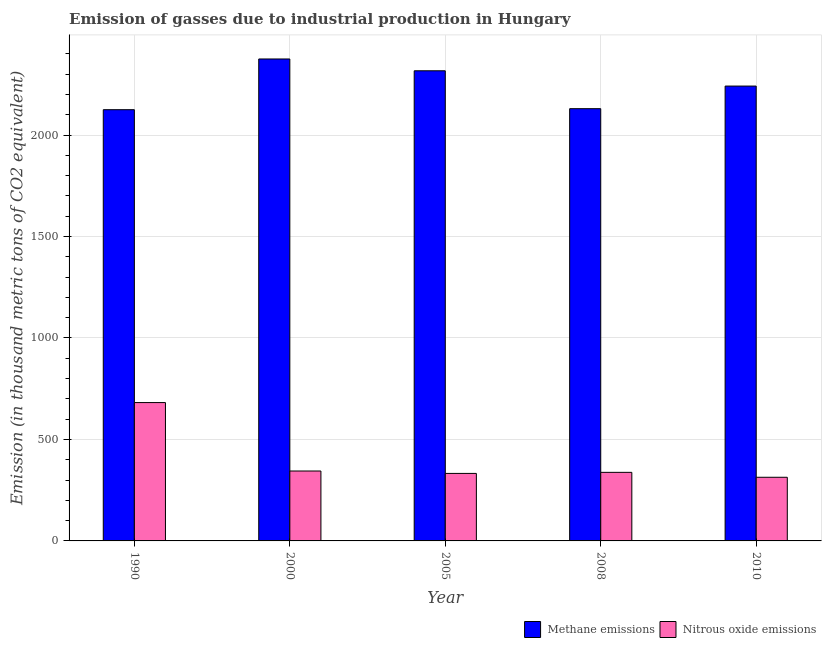How many different coloured bars are there?
Provide a succinct answer. 2. How many groups of bars are there?
Provide a short and direct response. 5. Are the number of bars on each tick of the X-axis equal?
Give a very brief answer. Yes. What is the label of the 2nd group of bars from the left?
Your response must be concise. 2000. What is the amount of nitrous oxide emissions in 2008?
Offer a very short reply. 337.9. Across all years, what is the maximum amount of nitrous oxide emissions?
Your answer should be compact. 681.7. Across all years, what is the minimum amount of nitrous oxide emissions?
Provide a succinct answer. 313.6. In which year was the amount of nitrous oxide emissions minimum?
Offer a terse response. 2010. What is the total amount of methane emissions in the graph?
Provide a short and direct response. 1.12e+04. What is the difference between the amount of nitrous oxide emissions in 1990 and that in 2008?
Keep it short and to the point. 343.8. What is the difference between the amount of methane emissions in 2008 and the amount of nitrous oxide emissions in 2010?
Provide a short and direct response. -111.4. What is the average amount of nitrous oxide emissions per year?
Ensure brevity in your answer.  402.06. What is the ratio of the amount of methane emissions in 2000 to that in 2005?
Give a very brief answer. 1.03. Is the amount of methane emissions in 2000 less than that in 2010?
Provide a short and direct response. No. Is the difference between the amount of methane emissions in 2000 and 2010 greater than the difference between the amount of nitrous oxide emissions in 2000 and 2010?
Offer a very short reply. No. What is the difference between the highest and the second highest amount of methane emissions?
Your answer should be very brief. 58.2. What is the difference between the highest and the lowest amount of methane emissions?
Your answer should be very brief. 249.9. What does the 2nd bar from the left in 2008 represents?
Provide a succinct answer. Nitrous oxide emissions. What does the 2nd bar from the right in 1990 represents?
Keep it short and to the point. Methane emissions. How many bars are there?
Give a very brief answer. 10. How many years are there in the graph?
Make the answer very short. 5. Are the values on the major ticks of Y-axis written in scientific E-notation?
Your answer should be compact. No. Does the graph contain any zero values?
Keep it short and to the point. No. How many legend labels are there?
Keep it short and to the point. 2. How are the legend labels stacked?
Provide a short and direct response. Horizontal. What is the title of the graph?
Offer a terse response. Emission of gasses due to industrial production in Hungary. Does "Primary income" appear as one of the legend labels in the graph?
Provide a succinct answer. No. What is the label or title of the Y-axis?
Offer a terse response. Emission (in thousand metric tons of CO2 equivalent). What is the Emission (in thousand metric tons of CO2 equivalent) of Methane emissions in 1990?
Offer a very short reply. 2124.8. What is the Emission (in thousand metric tons of CO2 equivalent) of Nitrous oxide emissions in 1990?
Your answer should be very brief. 681.7. What is the Emission (in thousand metric tons of CO2 equivalent) of Methane emissions in 2000?
Make the answer very short. 2374.7. What is the Emission (in thousand metric tons of CO2 equivalent) of Nitrous oxide emissions in 2000?
Keep it short and to the point. 344.5. What is the Emission (in thousand metric tons of CO2 equivalent) of Methane emissions in 2005?
Keep it short and to the point. 2316.5. What is the Emission (in thousand metric tons of CO2 equivalent) in Nitrous oxide emissions in 2005?
Keep it short and to the point. 332.6. What is the Emission (in thousand metric tons of CO2 equivalent) of Methane emissions in 2008?
Your answer should be very brief. 2129.8. What is the Emission (in thousand metric tons of CO2 equivalent) of Nitrous oxide emissions in 2008?
Give a very brief answer. 337.9. What is the Emission (in thousand metric tons of CO2 equivalent) in Methane emissions in 2010?
Your response must be concise. 2241.2. What is the Emission (in thousand metric tons of CO2 equivalent) of Nitrous oxide emissions in 2010?
Offer a terse response. 313.6. Across all years, what is the maximum Emission (in thousand metric tons of CO2 equivalent) in Methane emissions?
Provide a succinct answer. 2374.7. Across all years, what is the maximum Emission (in thousand metric tons of CO2 equivalent) in Nitrous oxide emissions?
Offer a terse response. 681.7. Across all years, what is the minimum Emission (in thousand metric tons of CO2 equivalent) in Methane emissions?
Your answer should be very brief. 2124.8. Across all years, what is the minimum Emission (in thousand metric tons of CO2 equivalent) of Nitrous oxide emissions?
Make the answer very short. 313.6. What is the total Emission (in thousand metric tons of CO2 equivalent) of Methane emissions in the graph?
Your answer should be very brief. 1.12e+04. What is the total Emission (in thousand metric tons of CO2 equivalent) of Nitrous oxide emissions in the graph?
Give a very brief answer. 2010.3. What is the difference between the Emission (in thousand metric tons of CO2 equivalent) in Methane emissions in 1990 and that in 2000?
Provide a short and direct response. -249.9. What is the difference between the Emission (in thousand metric tons of CO2 equivalent) of Nitrous oxide emissions in 1990 and that in 2000?
Offer a terse response. 337.2. What is the difference between the Emission (in thousand metric tons of CO2 equivalent) of Methane emissions in 1990 and that in 2005?
Keep it short and to the point. -191.7. What is the difference between the Emission (in thousand metric tons of CO2 equivalent) in Nitrous oxide emissions in 1990 and that in 2005?
Offer a very short reply. 349.1. What is the difference between the Emission (in thousand metric tons of CO2 equivalent) of Methane emissions in 1990 and that in 2008?
Provide a succinct answer. -5. What is the difference between the Emission (in thousand metric tons of CO2 equivalent) of Nitrous oxide emissions in 1990 and that in 2008?
Provide a succinct answer. 343.8. What is the difference between the Emission (in thousand metric tons of CO2 equivalent) in Methane emissions in 1990 and that in 2010?
Make the answer very short. -116.4. What is the difference between the Emission (in thousand metric tons of CO2 equivalent) in Nitrous oxide emissions in 1990 and that in 2010?
Provide a succinct answer. 368.1. What is the difference between the Emission (in thousand metric tons of CO2 equivalent) in Methane emissions in 2000 and that in 2005?
Give a very brief answer. 58.2. What is the difference between the Emission (in thousand metric tons of CO2 equivalent) of Methane emissions in 2000 and that in 2008?
Make the answer very short. 244.9. What is the difference between the Emission (in thousand metric tons of CO2 equivalent) in Methane emissions in 2000 and that in 2010?
Give a very brief answer. 133.5. What is the difference between the Emission (in thousand metric tons of CO2 equivalent) of Nitrous oxide emissions in 2000 and that in 2010?
Your response must be concise. 30.9. What is the difference between the Emission (in thousand metric tons of CO2 equivalent) in Methane emissions in 2005 and that in 2008?
Ensure brevity in your answer.  186.7. What is the difference between the Emission (in thousand metric tons of CO2 equivalent) of Methane emissions in 2005 and that in 2010?
Give a very brief answer. 75.3. What is the difference between the Emission (in thousand metric tons of CO2 equivalent) of Methane emissions in 2008 and that in 2010?
Your answer should be very brief. -111.4. What is the difference between the Emission (in thousand metric tons of CO2 equivalent) in Nitrous oxide emissions in 2008 and that in 2010?
Offer a very short reply. 24.3. What is the difference between the Emission (in thousand metric tons of CO2 equivalent) in Methane emissions in 1990 and the Emission (in thousand metric tons of CO2 equivalent) in Nitrous oxide emissions in 2000?
Provide a succinct answer. 1780.3. What is the difference between the Emission (in thousand metric tons of CO2 equivalent) in Methane emissions in 1990 and the Emission (in thousand metric tons of CO2 equivalent) in Nitrous oxide emissions in 2005?
Give a very brief answer. 1792.2. What is the difference between the Emission (in thousand metric tons of CO2 equivalent) of Methane emissions in 1990 and the Emission (in thousand metric tons of CO2 equivalent) of Nitrous oxide emissions in 2008?
Your response must be concise. 1786.9. What is the difference between the Emission (in thousand metric tons of CO2 equivalent) of Methane emissions in 1990 and the Emission (in thousand metric tons of CO2 equivalent) of Nitrous oxide emissions in 2010?
Keep it short and to the point. 1811.2. What is the difference between the Emission (in thousand metric tons of CO2 equivalent) in Methane emissions in 2000 and the Emission (in thousand metric tons of CO2 equivalent) in Nitrous oxide emissions in 2005?
Make the answer very short. 2042.1. What is the difference between the Emission (in thousand metric tons of CO2 equivalent) of Methane emissions in 2000 and the Emission (in thousand metric tons of CO2 equivalent) of Nitrous oxide emissions in 2008?
Offer a terse response. 2036.8. What is the difference between the Emission (in thousand metric tons of CO2 equivalent) in Methane emissions in 2000 and the Emission (in thousand metric tons of CO2 equivalent) in Nitrous oxide emissions in 2010?
Give a very brief answer. 2061.1. What is the difference between the Emission (in thousand metric tons of CO2 equivalent) of Methane emissions in 2005 and the Emission (in thousand metric tons of CO2 equivalent) of Nitrous oxide emissions in 2008?
Make the answer very short. 1978.6. What is the difference between the Emission (in thousand metric tons of CO2 equivalent) in Methane emissions in 2005 and the Emission (in thousand metric tons of CO2 equivalent) in Nitrous oxide emissions in 2010?
Provide a succinct answer. 2002.9. What is the difference between the Emission (in thousand metric tons of CO2 equivalent) of Methane emissions in 2008 and the Emission (in thousand metric tons of CO2 equivalent) of Nitrous oxide emissions in 2010?
Give a very brief answer. 1816.2. What is the average Emission (in thousand metric tons of CO2 equivalent) of Methane emissions per year?
Offer a very short reply. 2237.4. What is the average Emission (in thousand metric tons of CO2 equivalent) of Nitrous oxide emissions per year?
Provide a succinct answer. 402.06. In the year 1990, what is the difference between the Emission (in thousand metric tons of CO2 equivalent) of Methane emissions and Emission (in thousand metric tons of CO2 equivalent) of Nitrous oxide emissions?
Offer a terse response. 1443.1. In the year 2000, what is the difference between the Emission (in thousand metric tons of CO2 equivalent) of Methane emissions and Emission (in thousand metric tons of CO2 equivalent) of Nitrous oxide emissions?
Offer a terse response. 2030.2. In the year 2005, what is the difference between the Emission (in thousand metric tons of CO2 equivalent) in Methane emissions and Emission (in thousand metric tons of CO2 equivalent) in Nitrous oxide emissions?
Give a very brief answer. 1983.9. In the year 2008, what is the difference between the Emission (in thousand metric tons of CO2 equivalent) in Methane emissions and Emission (in thousand metric tons of CO2 equivalent) in Nitrous oxide emissions?
Make the answer very short. 1791.9. In the year 2010, what is the difference between the Emission (in thousand metric tons of CO2 equivalent) in Methane emissions and Emission (in thousand metric tons of CO2 equivalent) in Nitrous oxide emissions?
Your answer should be compact. 1927.6. What is the ratio of the Emission (in thousand metric tons of CO2 equivalent) in Methane emissions in 1990 to that in 2000?
Give a very brief answer. 0.89. What is the ratio of the Emission (in thousand metric tons of CO2 equivalent) in Nitrous oxide emissions in 1990 to that in 2000?
Offer a very short reply. 1.98. What is the ratio of the Emission (in thousand metric tons of CO2 equivalent) in Methane emissions in 1990 to that in 2005?
Make the answer very short. 0.92. What is the ratio of the Emission (in thousand metric tons of CO2 equivalent) in Nitrous oxide emissions in 1990 to that in 2005?
Make the answer very short. 2.05. What is the ratio of the Emission (in thousand metric tons of CO2 equivalent) of Methane emissions in 1990 to that in 2008?
Keep it short and to the point. 1. What is the ratio of the Emission (in thousand metric tons of CO2 equivalent) of Nitrous oxide emissions in 1990 to that in 2008?
Your response must be concise. 2.02. What is the ratio of the Emission (in thousand metric tons of CO2 equivalent) of Methane emissions in 1990 to that in 2010?
Provide a succinct answer. 0.95. What is the ratio of the Emission (in thousand metric tons of CO2 equivalent) in Nitrous oxide emissions in 1990 to that in 2010?
Provide a short and direct response. 2.17. What is the ratio of the Emission (in thousand metric tons of CO2 equivalent) in Methane emissions in 2000 to that in 2005?
Make the answer very short. 1.03. What is the ratio of the Emission (in thousand metric tons of CO2 equivalent) in Nitrous oxide emissions in 2000 to that in 2005?
Provide a short and direct response. 1.04. What is the ratio of the Emission (in thousand metric tons of CO2 equivalent) in Methane emissions in 2000 to that in 2008?
Offer a very short reply. 1.11. What is the ratio of the Emission (in thousand metric tons of CO2 equivalent) in Nitrous oxide emissions in 2000 to that in 2008?
Keep it short and to the point. 1.02. What is the ratio of the Emission (in thousand metric tons of CO2 equivalent) of Methane emissions in 2000 to that in 2010?
Provide a succinct answer. 1.06. What is the ratio of the Emission (in thousand metric tons of CO2 equivalent) in Nitrous oxide emissions in 2000 to that in 2010?
Keep it short and to the point. 1.1. What is the ratio of the Emission (in thousand metric tons of CO2 equivalent) in Methane emissions in 2005 to that in 2008?
Provide a short and direct response. 1.09. What is the ratio of the Emission (in thousand metric tons of CO2 equivalent) in Nitrous oxide emissions in 2005 to that in 2008?
Keep it short and to the point. 0.98. What is the ratio of the Emission (in thousand metric tons of CO2 equivalent) of Methane emissions in 2005 to that in 2010?
Provide a short and direct response. 1.03. What is the ratio of the Emission (in thousand metric tons of CO2 equivalent) in Nitrous oxide emissions in 2005 to that in 2010?
Make the answer very short. 1.06. What is the ratio of the Emission (in thousand metric tons of CO2 equivalent) in Methane emissions in 2008 to that in 2010?
Provide a short and direct response. 0.95. What is the ratio of the Emission (in thousand metric tons of CO2 equivalent) of Nitrous oxide emissions in 2008 to that in 2010?
Provide a succinct answer. 1.08. What is the difference between the highest and the second highest Emission (in thousand metric tons of CO2 equivalent) in Methane emissions?
Make the answer very short. 58.2. What is the difference between the highest and the second highest Emission (in thousand metric tons of CO2 equivalent) of Nitrous oxide emissions?
Offer a terse response. 337.2. What is the difference between the highest and the lowest Emission (in thousand metric tons of CO2 equivalent) of Methane emissions?
Provide a short and direct response. 249.9. What is the difference between the highest and the lowest Emission (in thousand metric tons of CO2 equivalent) in Nitrous oxide emissions?
Keep it short and to the point. 368.1. 